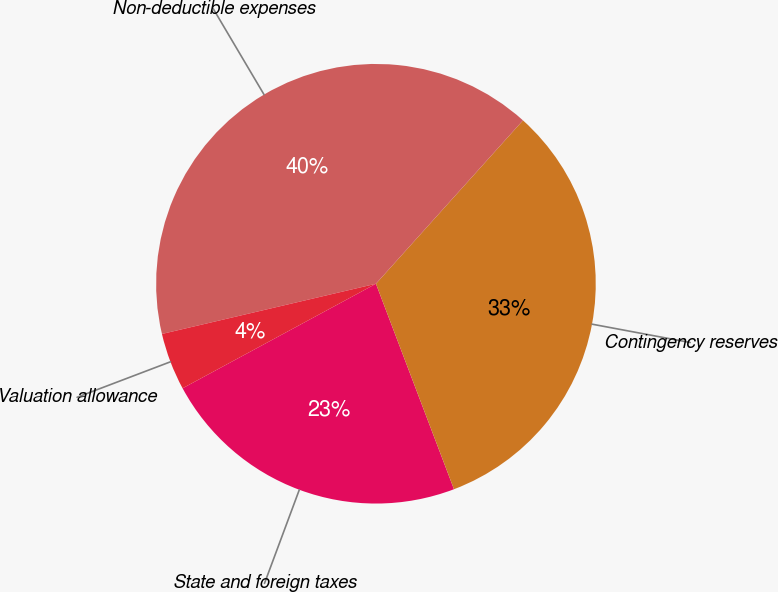Convert chart to OTSL. <chart><loc_0><loc_0><loc_500><loc_500><pie_chart><fcel>State and foreign taxes<fcel>Contingency reserves<fcel>Non-deductible expenses<fcel>Valuation allowance<nl><fcel>22.89%<fcel>32.56%<fcel>40.33%<fcel>4.22%<nl></chart> 